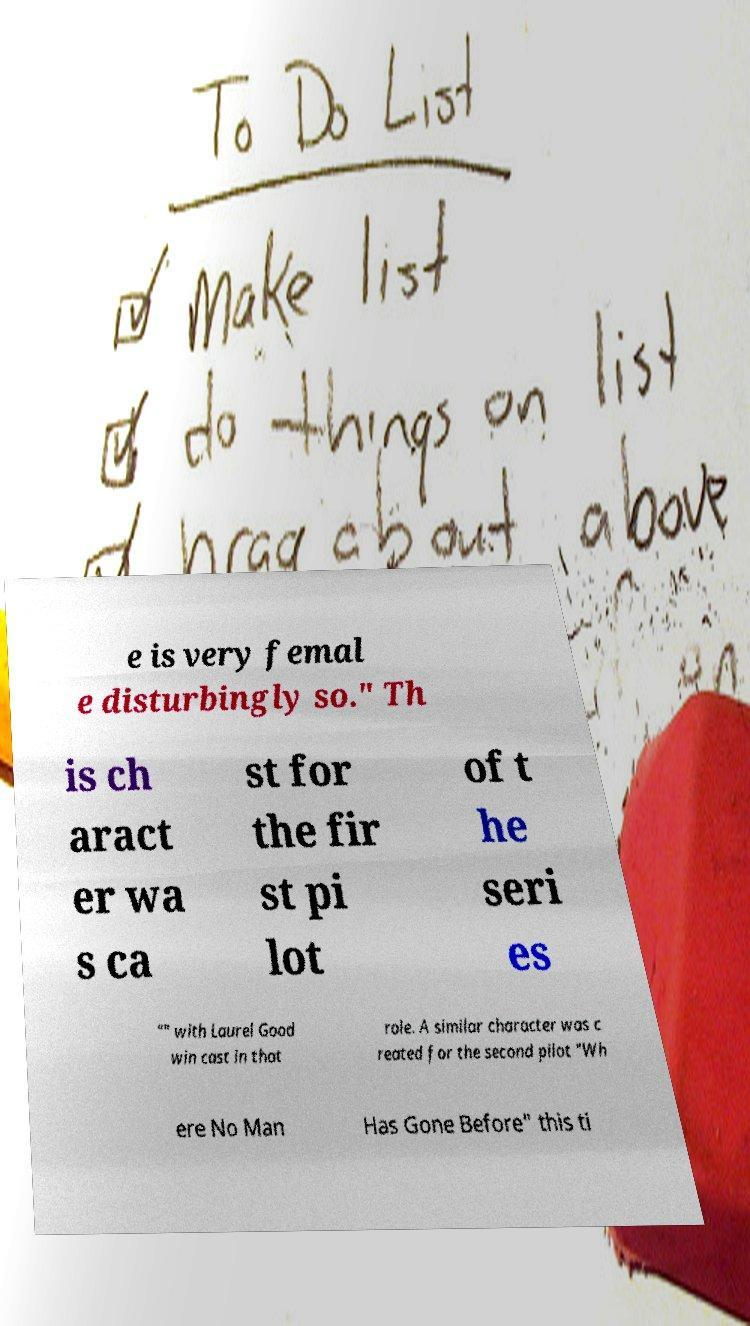Could you assist in decoding the text presented in this image and type it out clearly? e is very femal e disturbingly so." Th is ch aract er wa s ca st for the fir st pi lot of t he seri es "" with Laurel Good win cast in that role. A similar character was c reated for the second pilot "Wh ere No Man Has Gone Before" this ti 